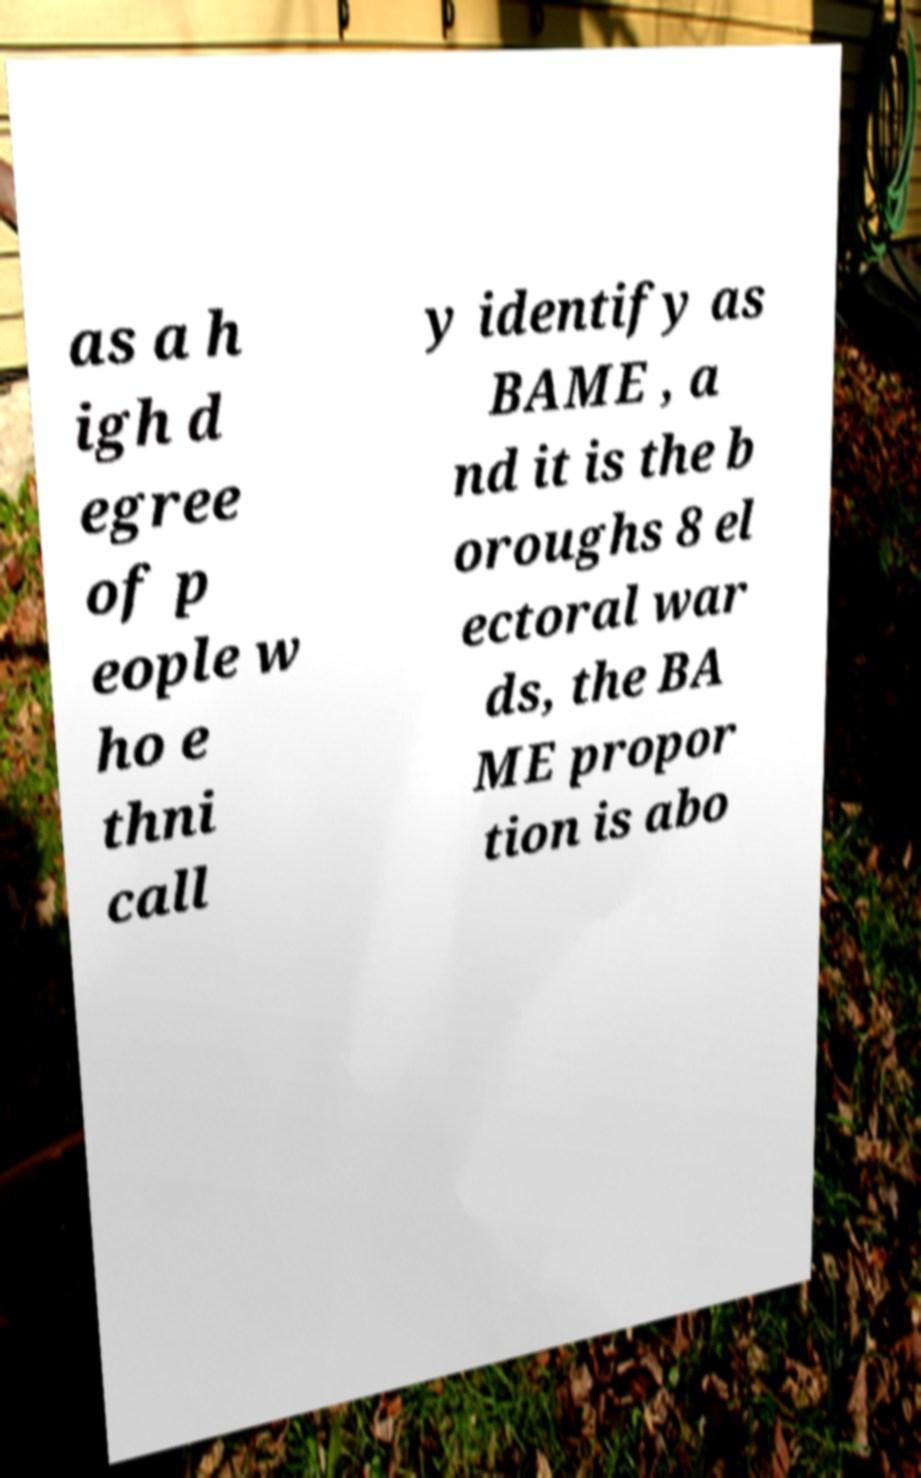Could you assist in decoding the text presented in this image and type it out clearly? as a h igh d egree of p eople w ho e thni call y identify as BAME , a nd it is the b oroughs 8 el ectoral war ds, the BA ME propor tion is abo 